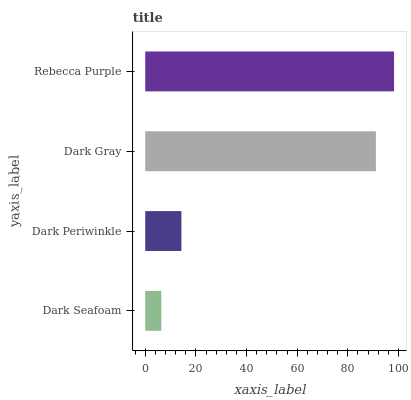Is Dark Seafoam the minimum?
Answer yes or no. Yes. Is Rebecca Purple the maximum?
Answer yes or no. Yes. Is Dark Periwinkle the minimum?
Answer yes or no. No. Is Dark Periwinkle the maximum?
Answer yes or no. No. Is Dark Periwinkle greater than Dark Seafoam?
Answer yes or no. Yes. Is Dark Seafoam less than Dark Periwinkle?
Answer yes or no. Yes. Is Dark Seafoam greater than Dark Periwinkle?
Answer yes or no. No. Is Dark Periwinkle less than Dark Seafoam?
Answer yes or no. No. Is Dark Gray the high median?
Answer yes or no. Yes. Is Dark Periwinkle the low median?
Answer yes or no. Yes. Is Rebecca Purple the high median?
Answer yes or no. No. Is Dark Seafoam the low median?
Answer yes or no. No. 